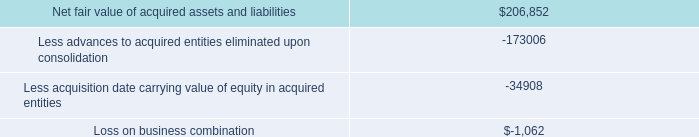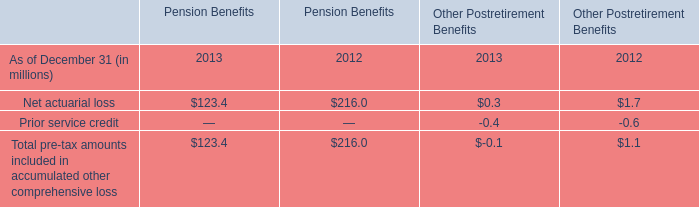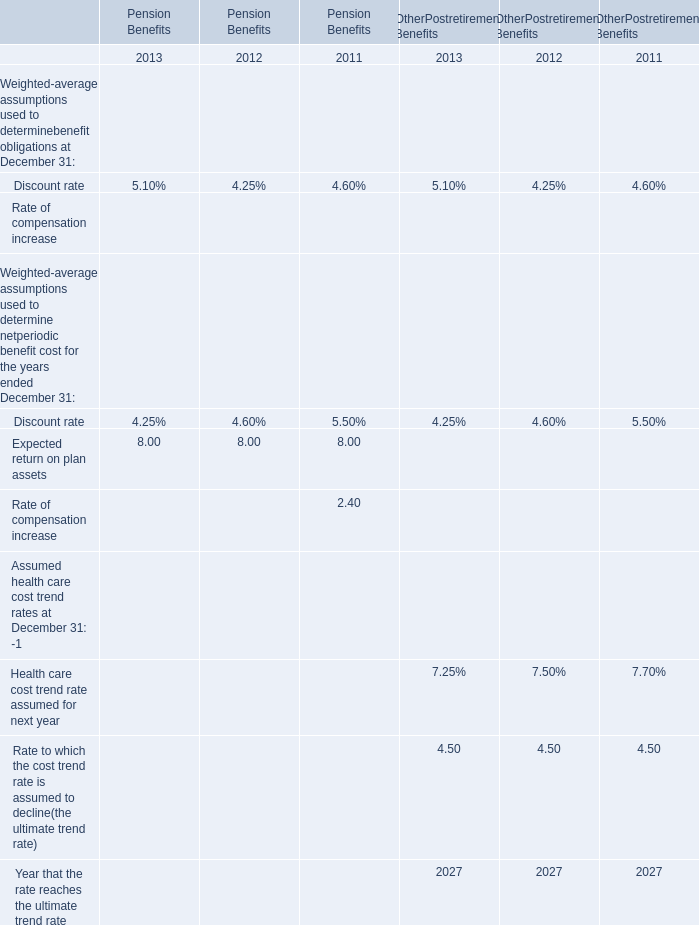In the year with lower value of the Net actuarial loss for Pension Benefits, what's the value of the Net actuarial loss for Other Postretirement Benefits? (in million) 
Answer: 0.3. 